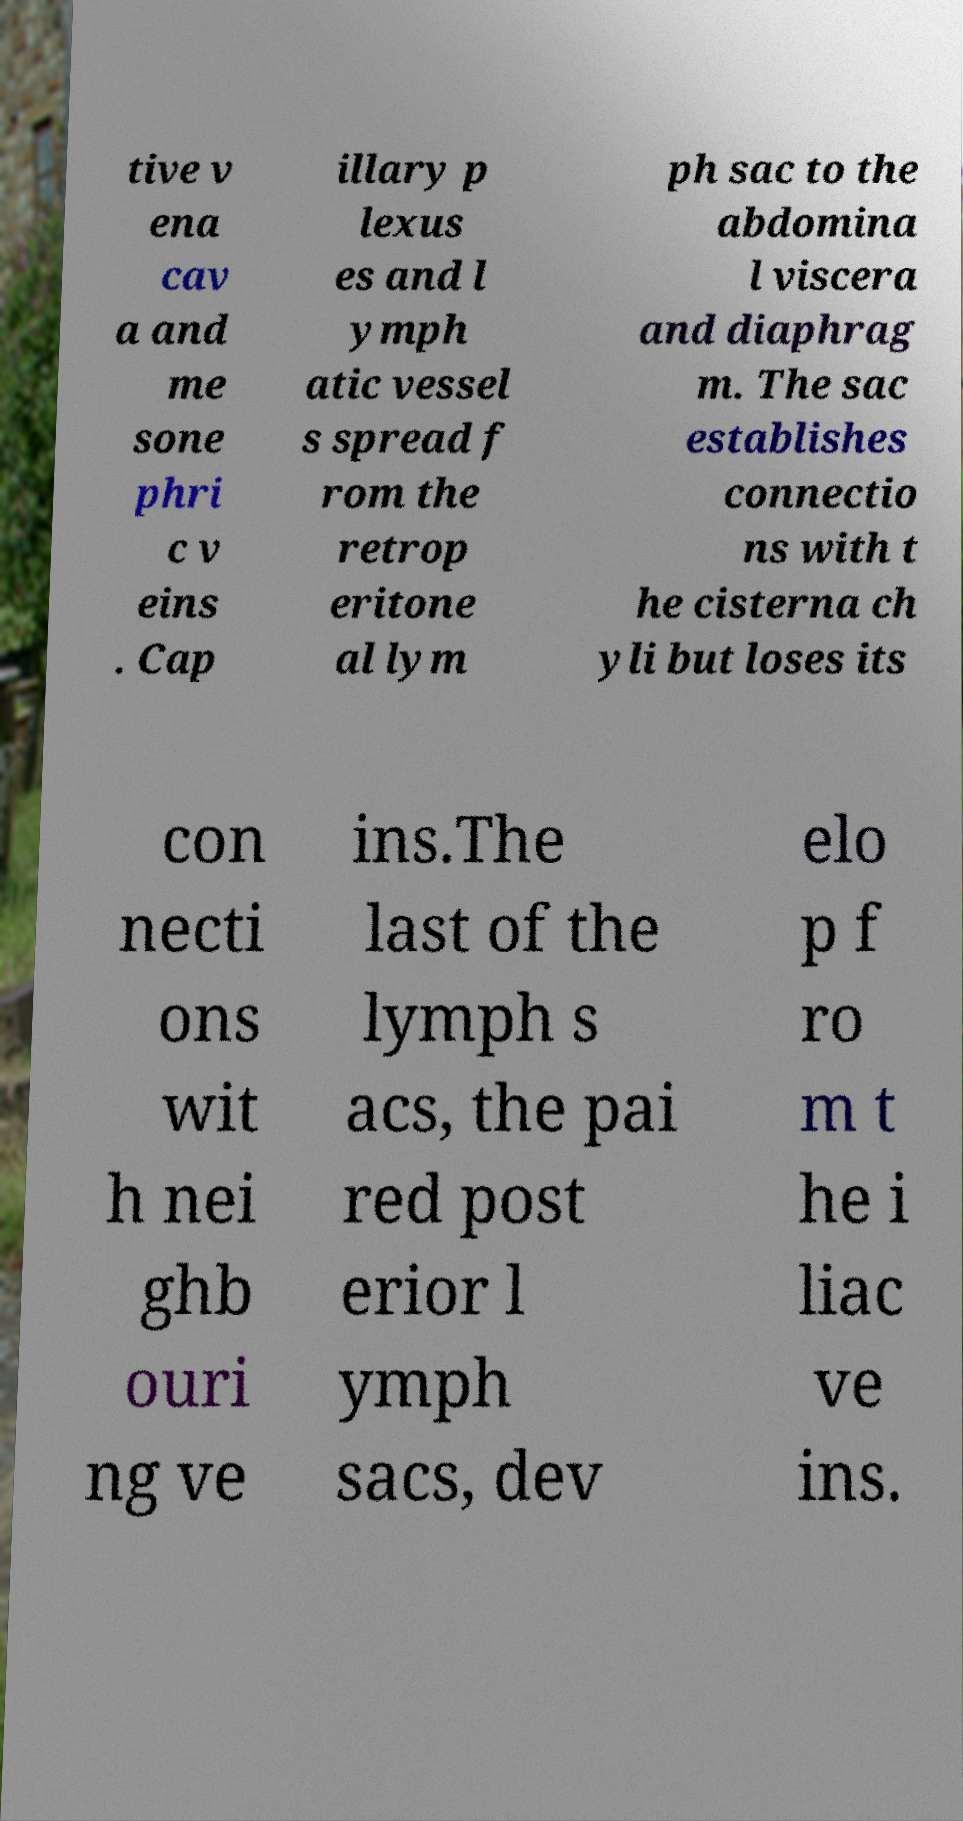Could you assist in decoding the text presented in this image and type it out clearly? tive v ena cav a and me sone phri c v eins . Cap illary p lexus es and l ymph atic vessel s spread f rom the retrop eritone al lym ph sac to the abdomina l viscera and diaphrag m. The sac establishes connectio ns with t he cisterna ch yli but loses its con necti ons wit h nei ghb ouri ng ve ins.The last of the lymph s acs, the pai red post erior l ymph sacs, dev elo p f ro m t he i liac ve ins. 